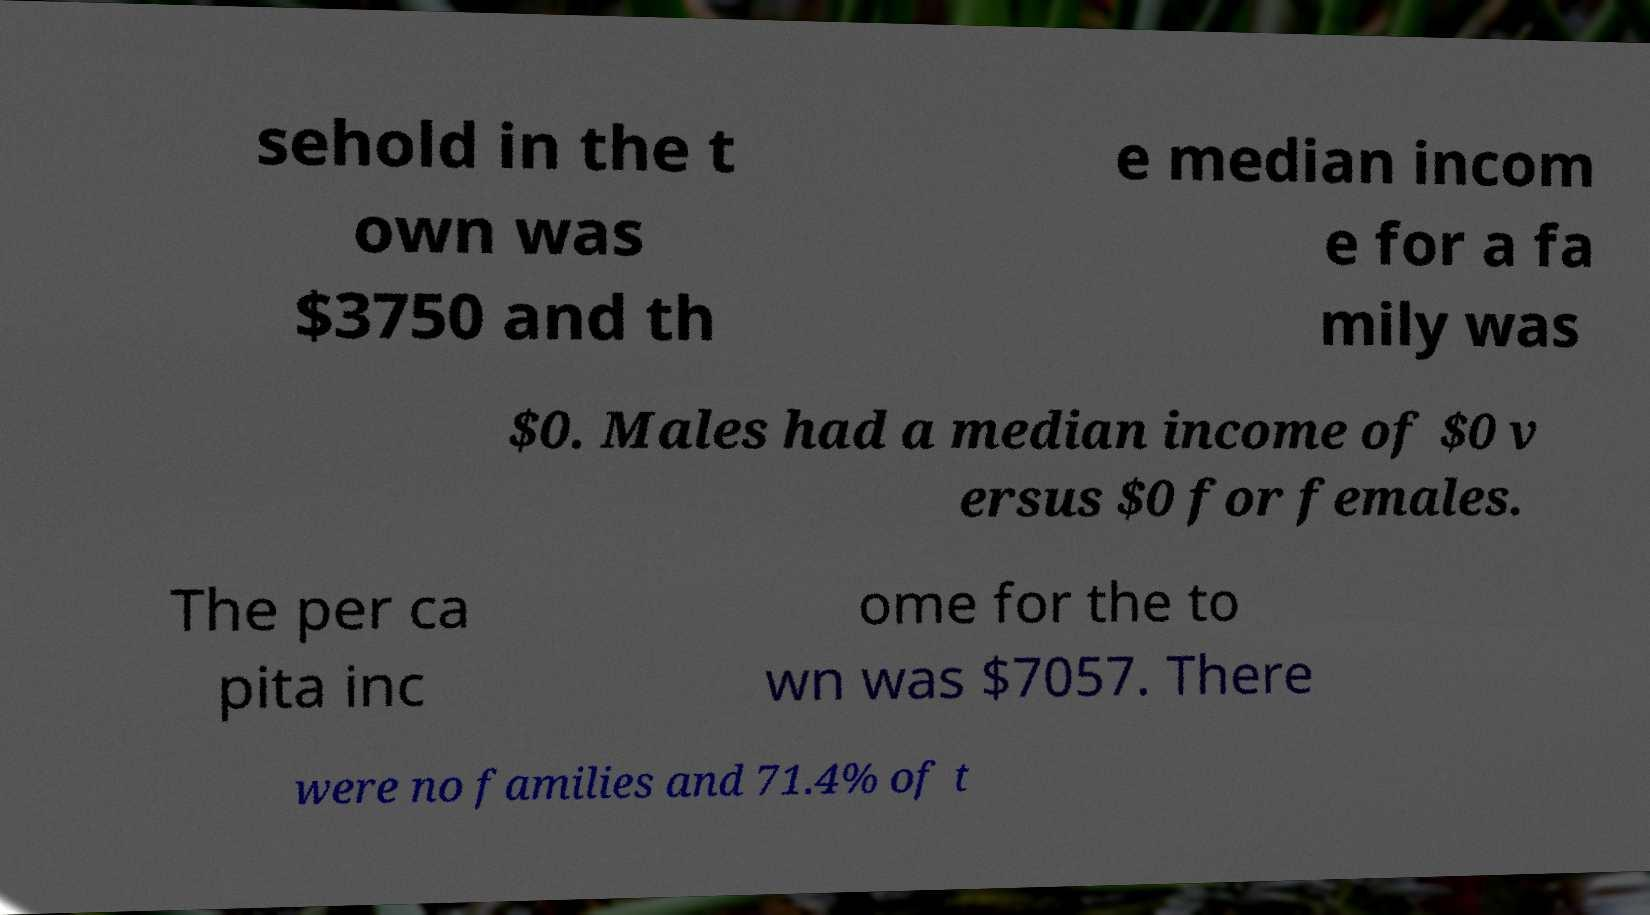For documentation purposes, I need the text within this image transcribed. Could you provide that? sehold in the t own was $3750 and th e median incom e for a fa mily was $0. Males had a median income of $0 v ersus $0 for females. The per ca pita inc ome for the to wn was $7057. There were no families and 71.4% of t 